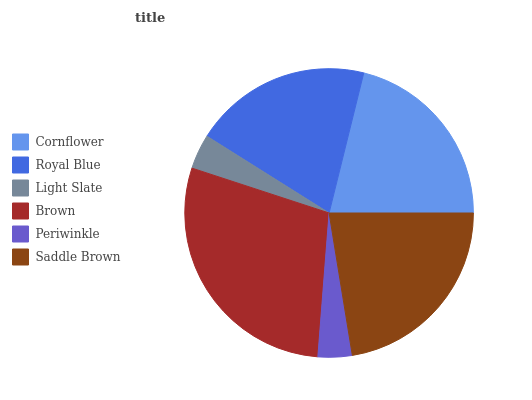Is Periwinkle the minimum?
Answer yes or no. Yes. Is Brown the maximum?
Answer yes or no. Yes. Is Royal Blue the minimum?
Answer yes or no. No. Is Royal Blue the maximum?
Answer yes or no. No. Is Cornflower greater than Royal Blue?
Answer yes or no. Yes. Is Royal Blue less than Cornflower?
Answer yes or no. Yes. Is Royal Blue greater than Cornflower?
Answer yes or no. No. Is Cornflower less than Royal Blue?
Answer yes or no. No. Is Cornflower the high median?
Answer yes or no. Yes. Is Royal Blue the low median?
Answer yes or no. Yes. Is Brown the high median?
Answer yes or no. No. Is Brown the low median?
Answer yes or no. No. 